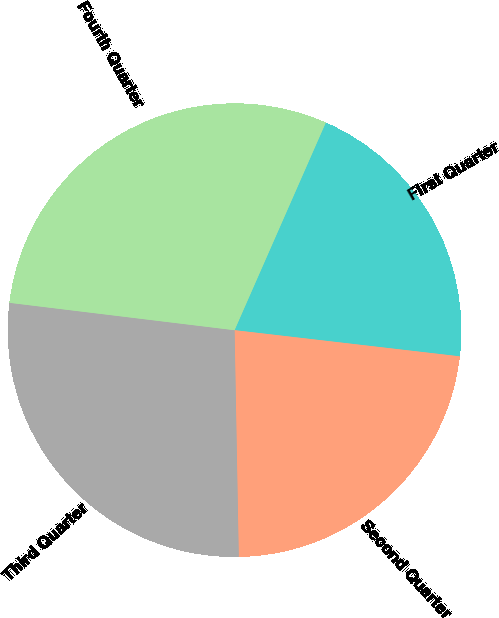<chart> <loc_0><loc_0><loc_500><loc_500><pie_chart><fcel>First Quarter<fcel>Second Quarter<fcel>Third Quarter<fcel>Fourth Quarter<nl><fcel>20.25%<fcel>22.86%<fcel>27.22%<fcel>29.66%<nl></chart> 